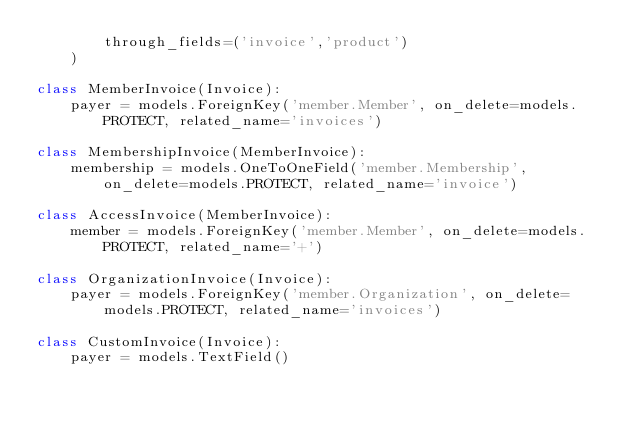<code> <loc_0><loc_0><loc_500><loc_500><_Python_>        through_fields=('invoice','product')
    )

class MemberInvoice(Invoice):
    payer = models.ForeignKey('member.Member', on_delete=models.PROTECT, related_name='invoices')

class MembershipInvoice(MemberInvoice):
    membership = models.OneToOneField('member.Membership', on_delete=models.PROTECT, related_name='invoice')

class AccessInvoice(MemberInvoice):
    member = models.ForeignKey('member.Member', on_delete=models.PROTECT, related_name='+')

class OrganizationInvoice(Invoice):
    payer = models.ForeignKey('member.Organization', on_delete=models.PROTECT, related_name='invoices')

class CustomInvoice(Invoice):
    payer = models.TextField()
</code> 